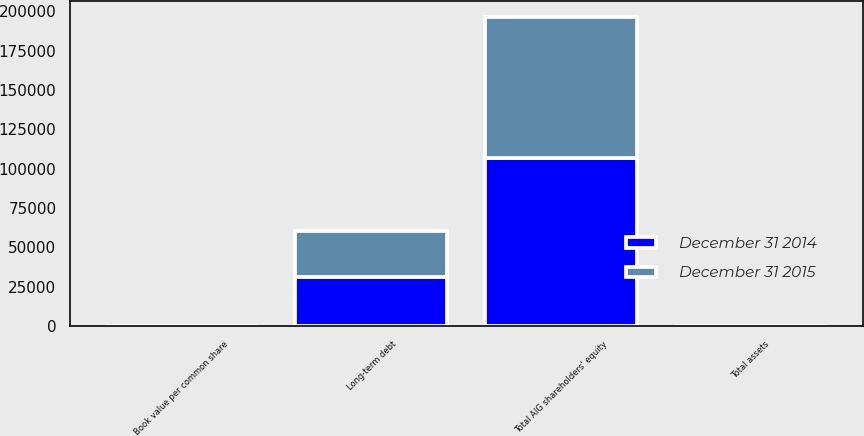<chart> <loc_0><loc_0><loc_500><loc_500><stacked_bar_chart><ecel><fcel>Total assets<fcel>Long-term debt<fcel>Total AIG shareholders' equity<fcel>Book value per common share<nl><fcel>December 31 2015<fcel>76.395<fcel>29350<fcel>89658<fcel>58.94<nl><fcel>December 31 2014<fcel>76.395<fcel>31217<fcel>106898<fcel>58.23<nl></chart> 